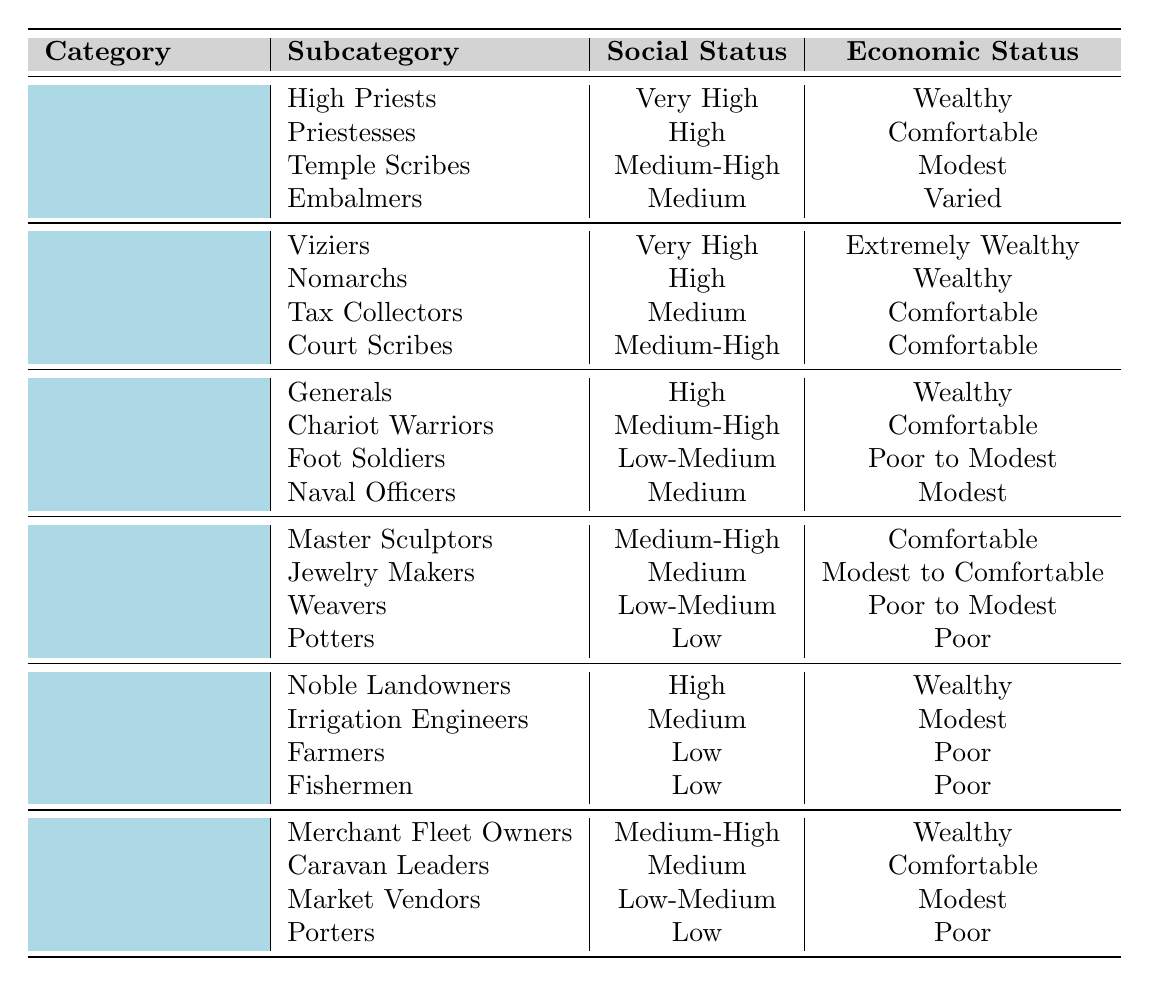What is the social status of High Priests in ancient Egyptian society? According to the table, High Priests fall under the Religious category, and their social status is listed as "Very High."
Answer: Very High Which profession has the highest economic status? The task requires checking the economic status across all categories. The Viziers, under the Administrative category, have the economic status of "Extremely Wealthy," which is the highest indicated.
Answer: Extremely Wealthy How many professions have a low economic status? From the table, the professions with a low economic status are Potters, Farmers, and Fishermen, totaling three professions.
Answer: Three Are there any artisans that have a very high social status? A review of the Artisans category shows that no profession listed has a very high social status; the highest listed is "Medium-High" for Master Sculptors.
Answer: No What is the average social status level of Military professions? The social statuses of Military professions are High, Medium-High, Low-Medium, and Medium. Assigning numerical values (e.g., Very High = 4, High = 3, Medium-High = 2, Medium = 1, Low-Medium = 0.5), the average is (3 + 2 + 0.5 + 1)/4 = 1.625, which corresponds to a social status between Medium and Medium-High.
Answer: Medium-High Which subcategory from the Trade category has the lowest economic status? Looking at the Trade category, Porters have the lowest economic status, which is listed as "Poor."
Answer: Poor Identify the profession with the highest social and economic standing in the Religious category. Within the Religious category, High Priests hold the highest social status ("Very High") and their economic status is "Wealthy."
Answer: High Priests How does the social status of Farmers compare to Noble Landowners? Farmers have a social status of "Low," while Noble Landowners hold a "High" social status. The comparison shows that Noble Landowners have a significantly higher social standing.
Answer: Noble Landowners have a higher status Which category contains the most professions classified as Medium economic status? Reviewing all categories, Agriculture has two professions (Irrigation Engineers and Farmers) listed with Medium economic status, which is the highest count compared to the other categories.
Answer: Agriculture Is there a military profession that falls under the Medium economic status? Yes, upon reviewing the Military category, Naval Officers are listed with a Medium economic status.
Answer: Yes 